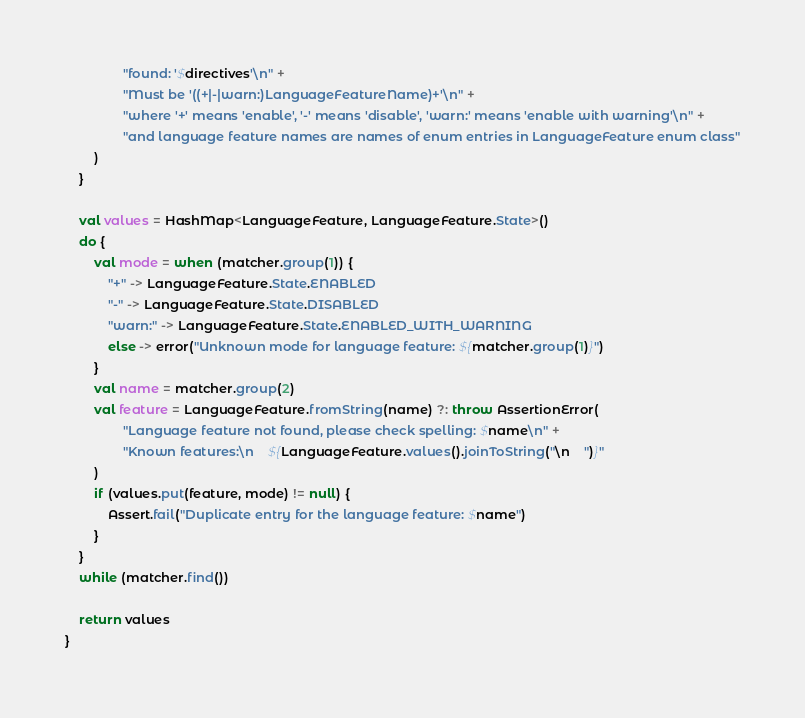<code> <loc_0><loc_0><loc_500><loc_500><_Kotlin_>                "found: '$directives'\n" +
                "Must be '((+|-|warn:)LanguageFeatureName)+'\n" +
                "where '+' means 'enable', '-' means 'disable', 'warn:' means 'enable with warning'\n" +
                "and language feature names are names of enum entries in LanguageFeature enum class"
        )
    }

    val values = HashMap<LanguageFeature, LanguageFeature.State>()
    do {
        val mode = when (matcher.group(1)) {
            "+" -> LanguageFeature.State.ENABLED
            "-" -> LanguageFeature.State.DISABLED
            "warn:" -> LanguageFeature.State.ENABLED_WITH_WARNING
            else -> error("Unknown mode for language feature: ${matcher.group(1)}")
        }
        val name = matcher.group(2)
        val feature = LanguageFeature.fromString(name) ?: throw AssertionError(
                "Language feature not found, please check spelling: $name\n" +
                "Known features:\n    ${LanguageFeature.values().joinToString("\n    ")}"
        )
        if (values.put(feature, mode) != null) {
            Assert.fail("Duplicate entry for the language feature: $name")
        }
    }
    while (matcher.find())

    return values
}
</code> 